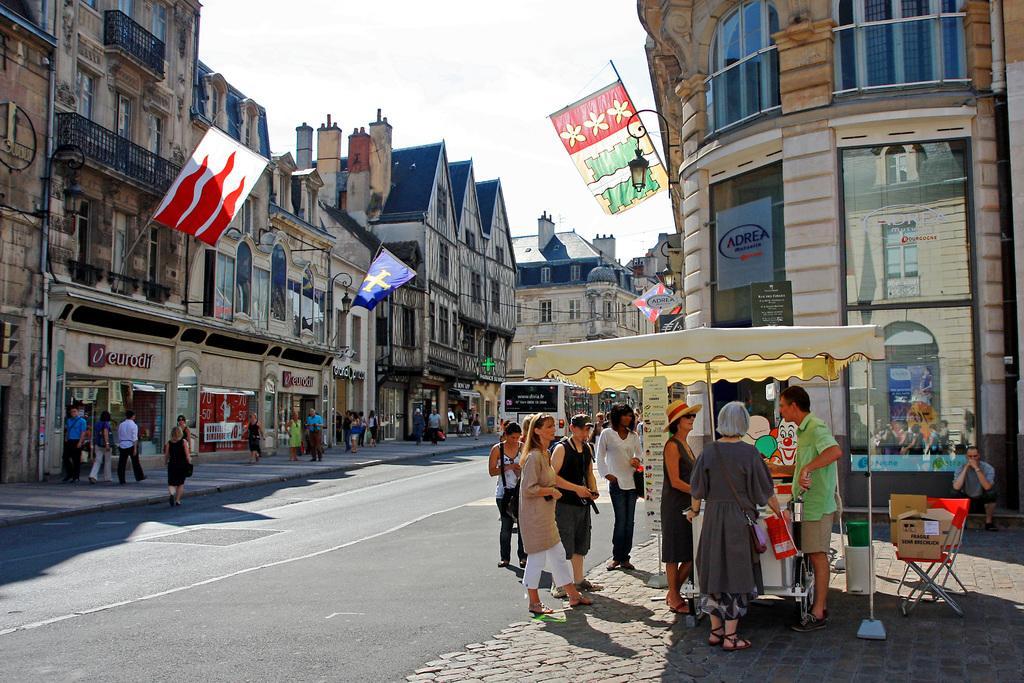Please provide a concise description of this image. In this picture, we can see a few buildings with windows, flags, doors, lights, fencing, glass doors, and we can see the road, vehicles, a few people, path and some object on the path like chairs, poles, boxes, and we can see posters and the sky. 